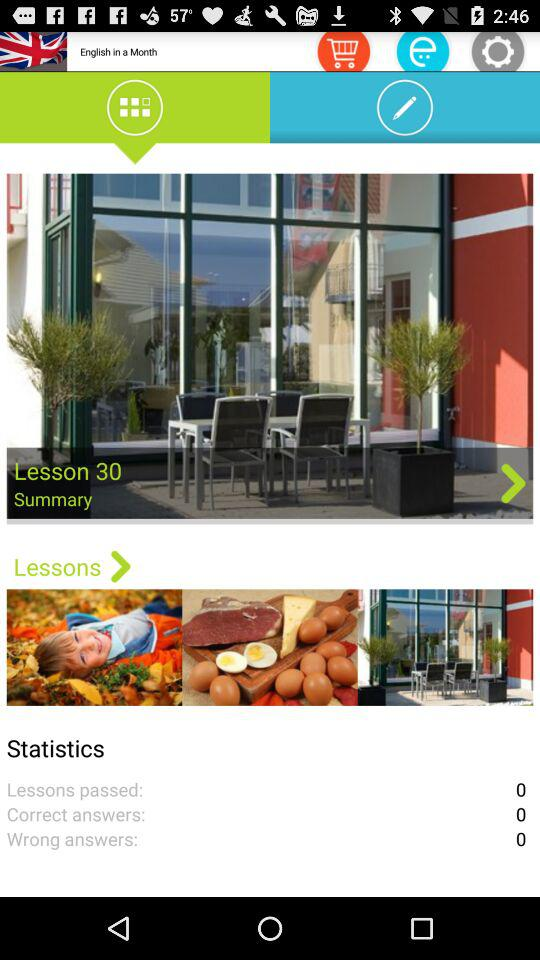What is the name of lesson 30? The name of lesson 30 is "Summary". 